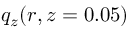Convert formula to latex. <formula><loc_0><loc_0><loc_500><loc_500>q _ { z } ( r , z = 0 . 0 5 )</formula> 